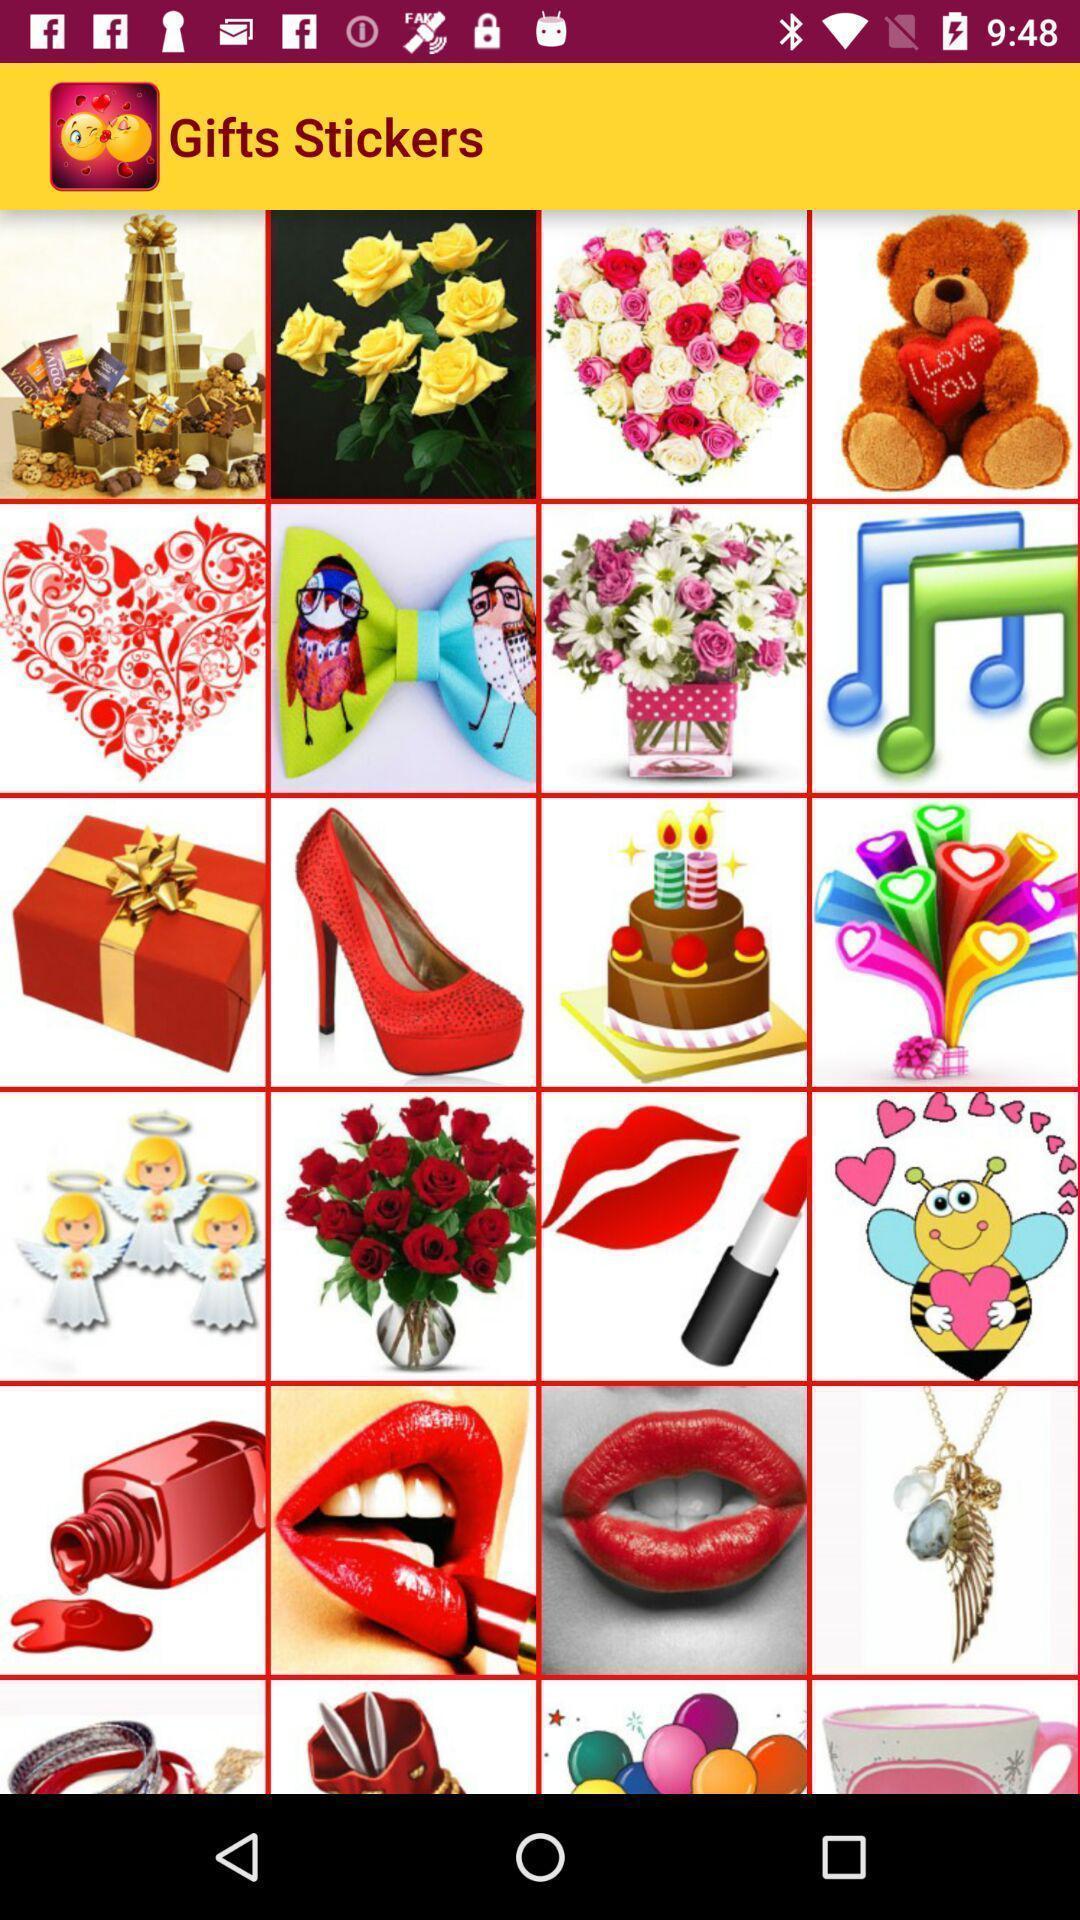Give me a narrative description of this picture. Screen displaying a list of images. 